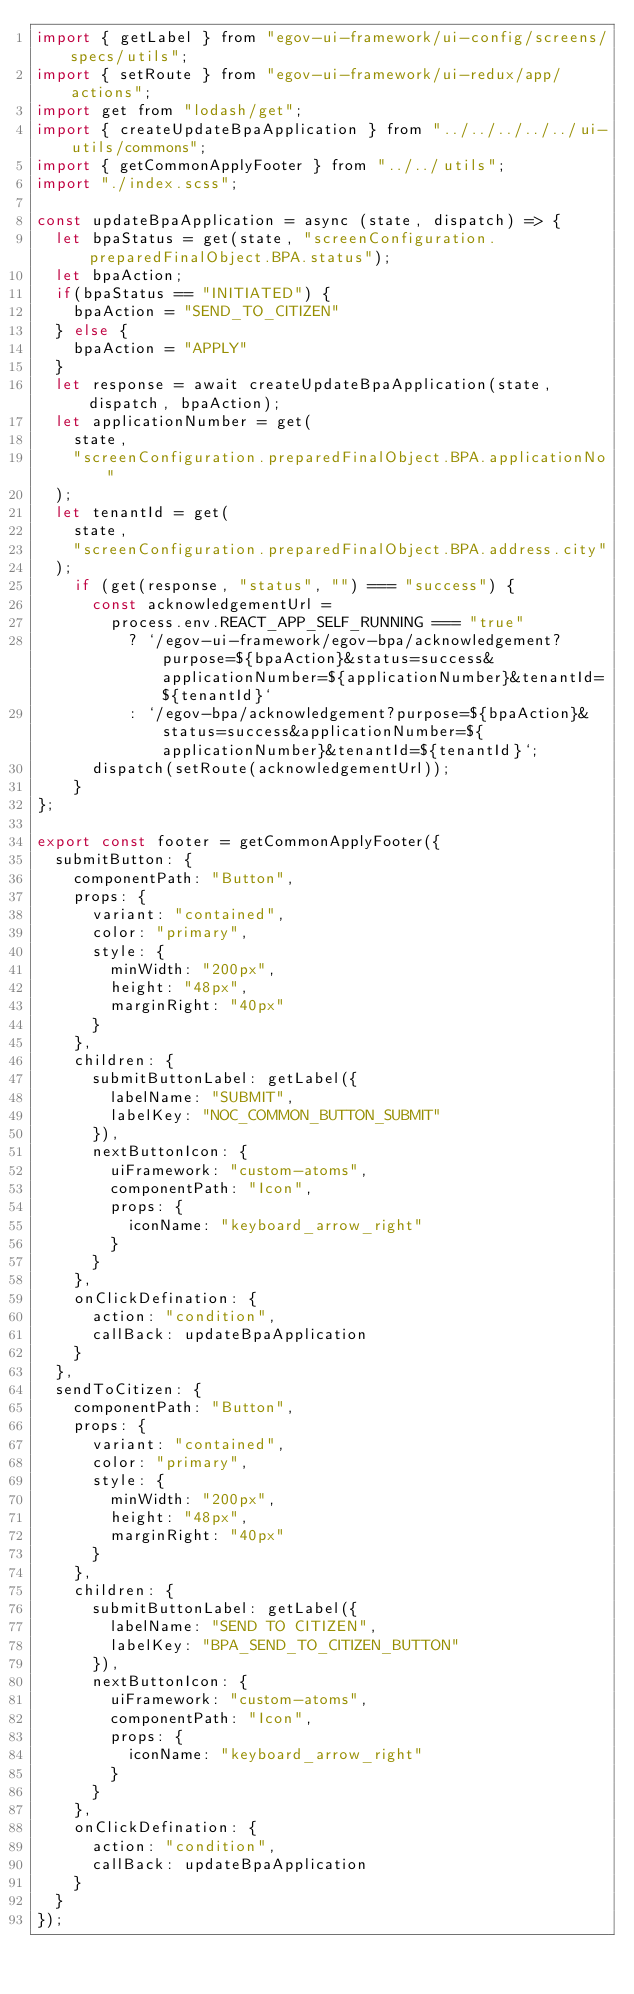<code> <loc_0><loc_0><loc_500><loc_500><_JavaScript_>import { getLabel } from "egov-ui-framework/ui-config/screens/specs/utils";
import { setRoute } from "egov-ui-framework/ui-redux/app/actions";
import get from "lodash/get";
import { createUpdateBpaApplication } from "../../../../../ui-utils/commons";
import { getCommonApplyFooter } from "../../utils";
import "./index.scss";

const updateBpaApplication = async (state, dispatch) => {
  let bpaStatus = get(state, "screenConfiguration.preparedFinalObject.BPA.status");
  let bpaAction;
  if(bpaStatus == "INITIATED") {
    bpaAction = "SEND_TO_CITIZEN"
  } else {
    bpaAction = "APPLY"
  }
  let response = await createUpdateBpaApplication(state, dispatch, bpaAction);
  let applicationNumber = get(
    state,
    "screenConfiguration.preparedFinalObject.BPA.applicationNo"
  );
  let tenantId = get(
    state,
    "screenConfiguration.preparedFinalObject.BPA.address.city"
  );
    if (get(response, "status", "") === "success") {
      const acknowledgementUrl =
        process.env.REACT_APP_SELF_RUNNING === "true"
          ? `/egov-ui-framework/egov-bpa/acknowledgement?purpose=${bpaAction}&status=success&applicationNumber=${applicationNumber}&tenantId=${tenantId}`
          : `/egov-bpa/acknowledgement?purpose=${bpaAction}&status=success&applicationNumber=${applicationNumber}&tenantId=${tenantId}`;
      dispatch(setRoute(acknowledgementUrl));
    }
};

export const footer = getCommonApplyFooter({
  submitButton: {
    componentPath: "Button",
    props: {
      variant: "contained",
      color: "primary",
      style: {
        minWidth: "200px",
        height: "48px",
        marginRight: "40px"
      }
    },
    children: {
      submitButtonLabel: getLabel({
        labelName: "SUBMIT",
        labelKey: "NOC_COMMON_BUTTON_SUBMIT"
      }),
      nextButtonIcon: {
        uiFramework: "custom-atoms",
        componentPath: "Icon",
        props: {
          iconName: "keyboard_arrow_right"
        }
      }
    },
    onClickDefination: {
      action: "condition",
      callBack: updateBpaApplication
    }
  },
  sendToCitizen: {
    componentPath: "Button",
    props: {
      variant: "contained",
      color: "primary",
      style: {
        minWidth: "200px",
        height: "48px",
        marginRight: "40px"
      }
    },
    children: {
      submitButtonLabel: getLabel({
        labelName: "SEND TO CITIZEN",
        labelKey: "BPA_SEND_TO_CITIZEN_BUTTON"
      }),
      nextButtonIcon: {
        uiFramework: "custom-atoms",
        componentPath: "Icon",
        props: {
          iconName: "keyboard_arrow_right"
        }
      }
    },
    onClickDefination: {
      action: "condition",
      callBack: updateBpaApplication
    }
  }
});
</code> 